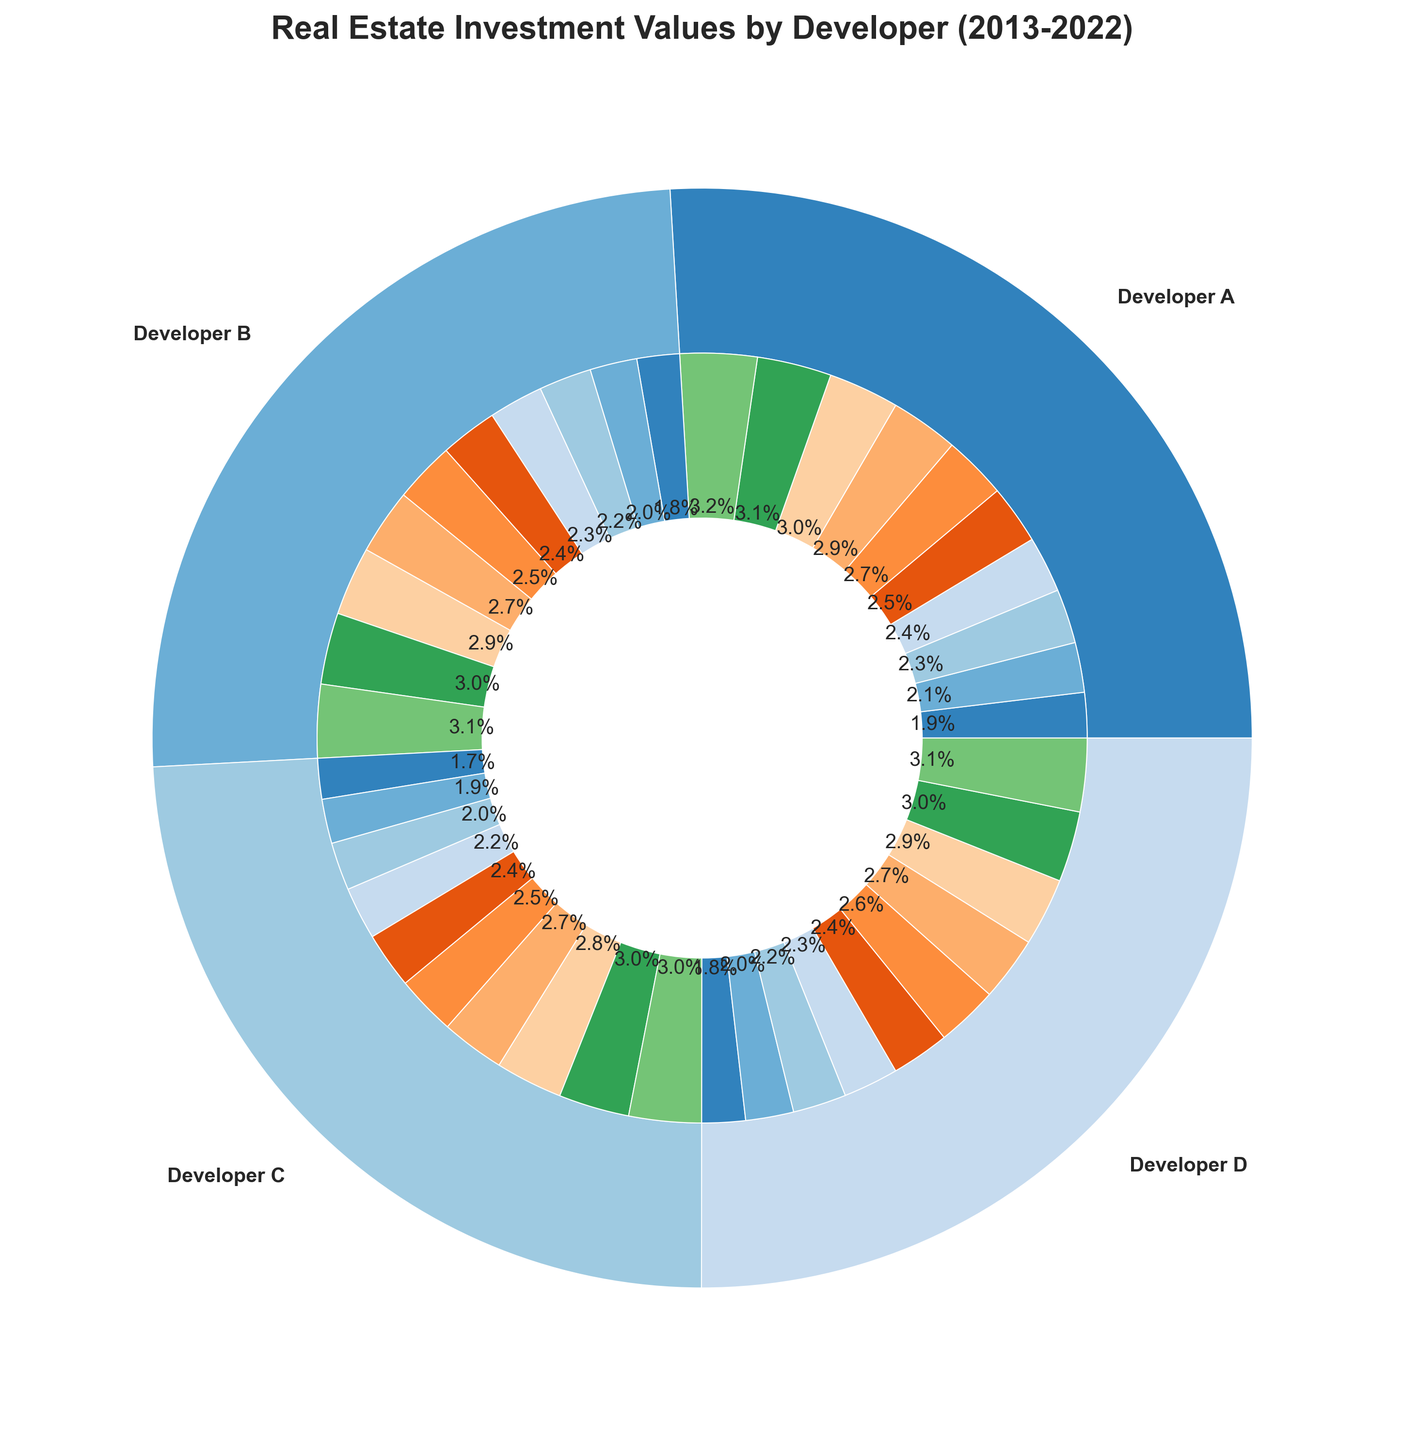How does the investment of Developer A in 2019 compare to Developer C in the same year? To compare, look at the inner pie chart slices corresponding to 2019 for both Developer A and Developer C. The color-coded slices show that Developer A has an investment of $750,000 and Developer C has $700,000 in 2019. Therefore, Developer A's investment is higher.
Answer: Developer A’s investment is higher Which year had the highest combined investment value across all developers? To determine the year with the highest combined investment value, sum the inner slices of all developers for each year. The year with the largest pie slice sum is 2022.
Answer: 2022 Which developer had the highest overall investment over the decade? Look at the outer pie chart slices; the largest slice represents the developer with the highest total investment. Developer A's outer slice is the largest.
Answer: Developer A What is the difference in total investment between Developer B and Developer D over the decade? Summing the total investments for Developer B and Developer D from the outer pie chart, Developer B’s total investment is $7,110,000 and Developer D’s is $7,640,000. The difference is $7,640,000 - $7,110,000 = $530,000.
Answer: $530,000 What is the average annual investment value of Developer C from 2013 to 2022? Calculate the average by summing Developer C’s annual investments and dividing by the number of years. Sum: $450,000 + $490,000 + $530,000 + $580,000 + $620,000 + $660,000 + $700,000 + $740,000 + $780,000 + $800,000 = $6,350,000. Average: $6,350,000 / 10 = $635,000.
Answer: $635,000 Did any developer invest less in 2018 than they did in 2017? Compare the inner slices for 2017 and 2018 for all developers. Both Developer B and Developer C increased their investment, as did Developer A. However, Developer D increased as well from $640,000 in 2017 to $680,000 in 2018. No developer invested less in 2018 than in 2017.
Answer: No What percentage of the total investment in 2020 was made by Developer A? Find Developer A’s investment value for 2020 ($780,000) and the combined investment for 2020. Total: $780,000 (A) + $760,000 (B) + $740,000 (C) + $750,000 (D) = $3,030,000. Percentage: ($780,000 / $3,030,000) * 100 ≈ 25.7%.
Answer: 25.7% Which developer showed the most consistent annual investment increase over the decade? By examining the inner pies for each developer from 2013 to 2022, every developer shows increments almost annually. Developer A had a consistent increase every year without any decrease, which indicates the most consistency.
Answer: Developer A 